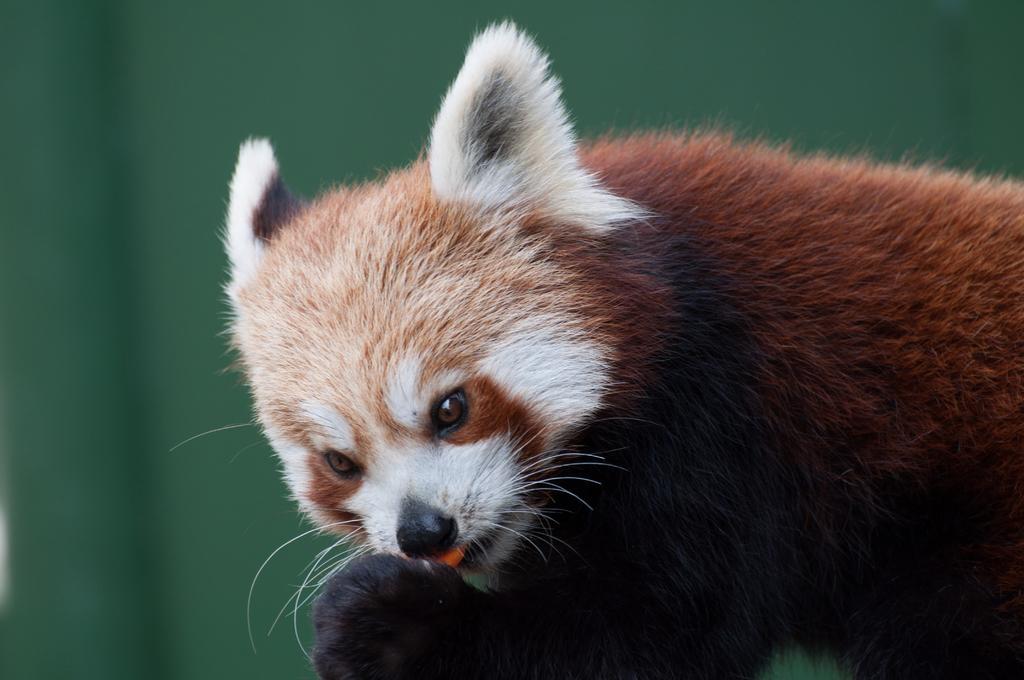In one or two sentences, can you explain what this image depicts? Here we can see brown and white color animal. Background it is in green color. 